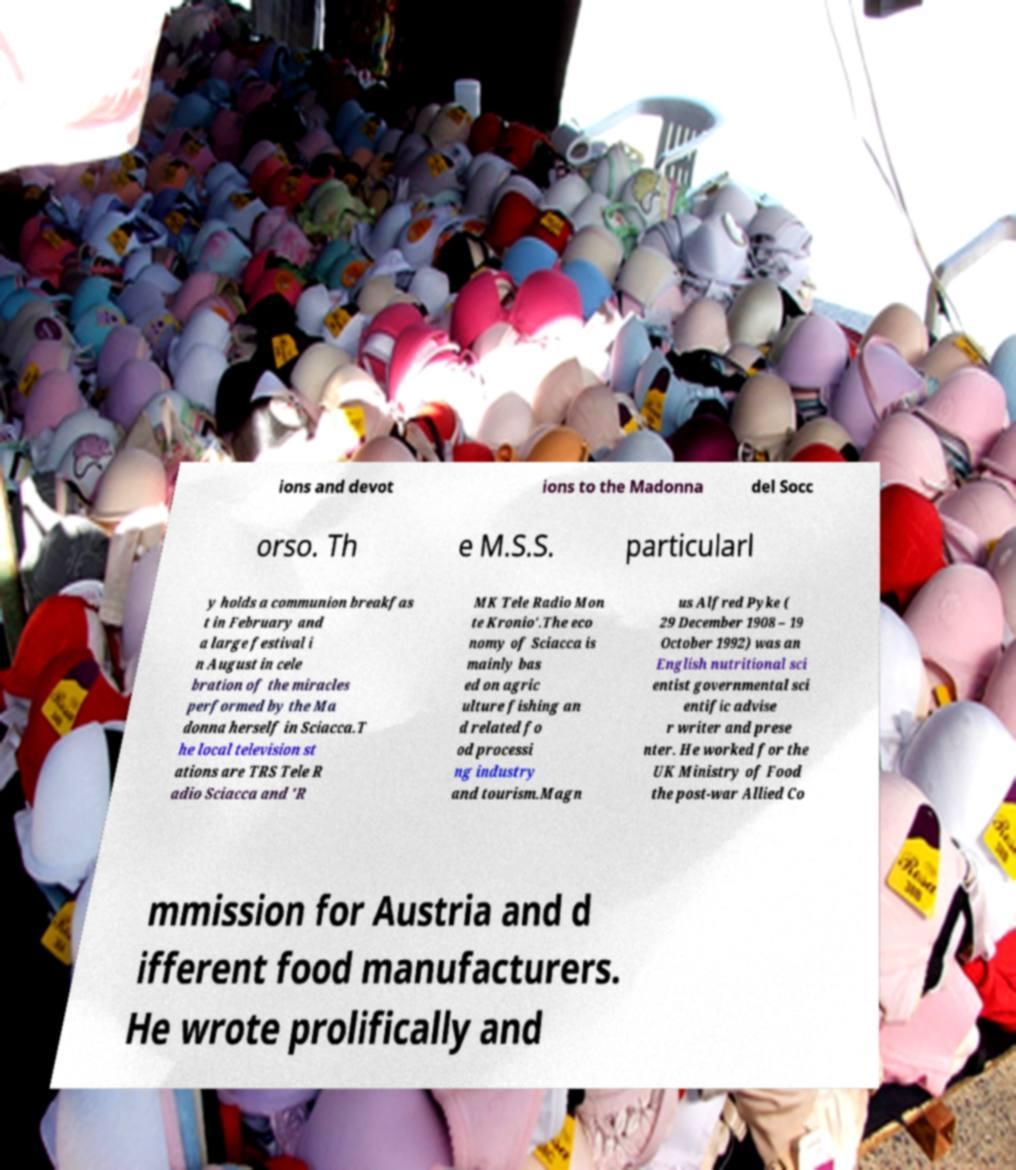Please identify and transcribe the text found in this image. ions and devot ions to the Madonna del Socc orso. Th e M.S.S. particularl y holds a communion breakfas t in February and a large festival i n August in cele bration of the miracles performed by the Ma donna herself in Sciacca.T he local television st ations are TRS Tele R adio Sciacca and 'R MK Tele Radio Mon te Kronio'.The eco nomy of Sciacca is mainly bas ed on agric ulture fishing an d related fo od processi ng industry and tourism.Magn us Alfred Pyke ( 29 December 1908 – 19 October 1992) was an English nutritional sci entist governmental sci entific advise r writer and prese nter. He worked for the UK Ministry of Food the post-war Allied Co mmission for Austria and d ifferent food manufacturers. He wrote prolifically and 